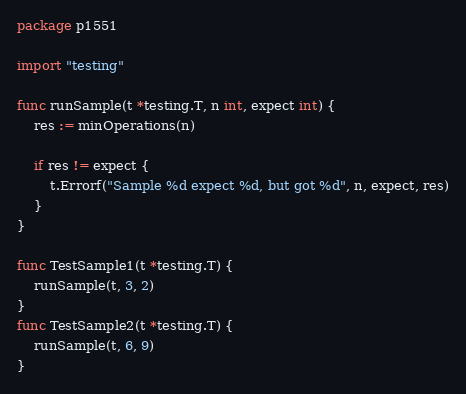Convert code to text. <code><loc_0><loc_0><loc_500><loc_500><_Go_>package p1551

import "testing"

func runSample(t *testing.T, n int, expect int) {
	res := minOperations(n)

	if res != expect {
		t.Errorf("Sample %d expect %d, but got %d", n, expect, res)
	}
}

func TestSample1(t *testing.T) {
	runSample(t, 3, 2)
}
func TestSample2(t *testing.T) {
	runSample(t, 6, 9)
}
</code> 